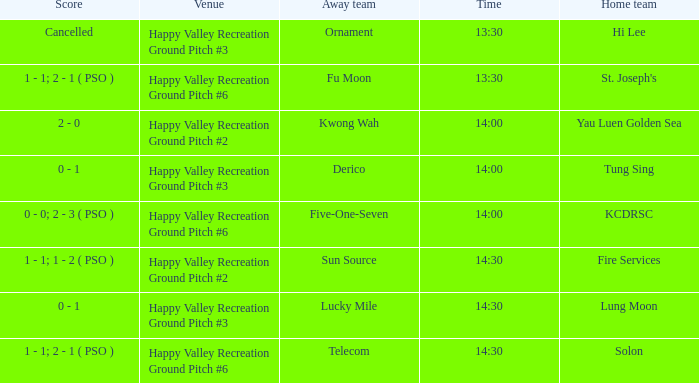What is the score of the match at happy valley recreation ground pitch #2 with a 14:30 time? 1 - 1; 1 - 2 ( PSO ). Help me parse the entirety of this table. {'header': ['Score', 'Venue', 'Away team', 'Time', 'Home team'], 'rows': [['Cancelled', 'Happy Valley Recreation Ground Pitch #3', 'Ornament', '13:30', 'Hi Lee'], ['1 - 1; 2 - 1 ( PSO )', 'Happy Valley Recreation Ground Pitch #6', 'Fu Moon', '13:30', "St. Joseph's"], ['2 - 0', 'Happy Valley Recreation Ground Pitch #2', 'Kwong Wah', '14:00', 'Yau Luen Golden Sea'], ['0 - 1', 'Happy Valley Recreation Ground Pitch #3', 'Derico', '14:00', 'Tung Sing'], ['0 - 0; 2 - 3 ( PSO )', 'Happy Valley Recreation Ground Pitch #6', 'Five-One-Seven', '14:00', 'KCDRSC'], ['1 - 1; 1 - 2 ( PSO )', 'Happy Valley Recreation Ground Pitch #2', 'Sun Source', '14:30', 'Fire Services'], ['0 - 1', 'Happy Valley Recreation Ground Pitch #3', 'Lucky Mile', '14:30', 'Lung Moon'], ['1 - 1; 2 - 1 ( PSO )', 'Happy Valley Recreation Ground Pitch #6', 'Telecom', '14:30', 'Solon']]} 